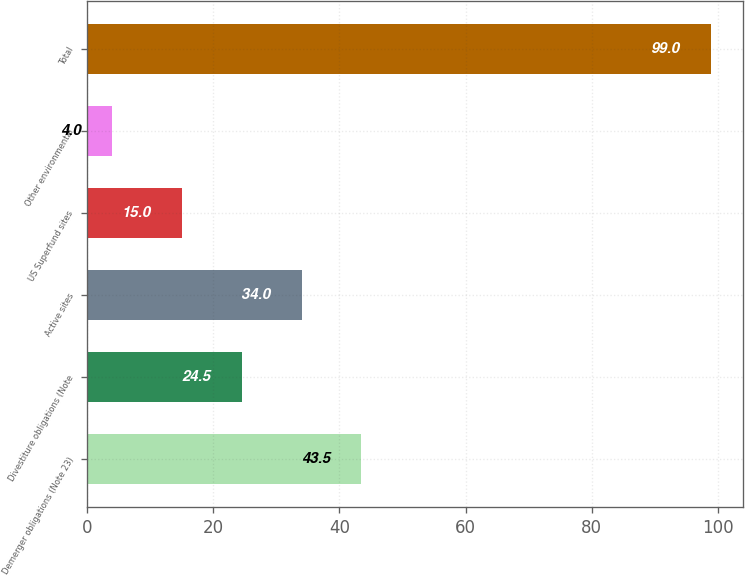Convert chart to OTSL. <chart><loc_0><loc_0><loc_500><loc_500><bar_chart><fcel>Demerger obligations (Note 23)<fcel>Divestiture obligations (Note<fcel>Active sites<fcel>US Superfund sites<fcel>Other environmental<fcel>Total<nl><fcel>43.5<fcel>24.5<fcel>34<fcel>15<fcel>4<fcel>99<nl></chart> 